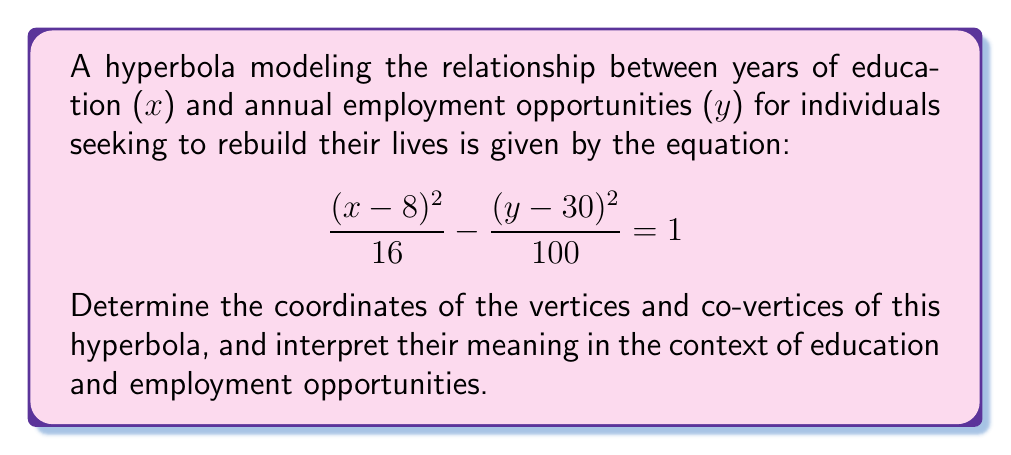Can you solve this math problem? Let's approach this step-by-step:

1) The standard form of a hyperbola with center (h,k) is:

   $$ \frac{(x-h)^2}{a^2} - \frac{(y-k)^2}{b^2} = 1 $$

   where the transverse axis is horizontal if $a^2 > b^2$, and vertical if $b^2 > a^2$.

2) Comparing our equation to the standard form:
   
   $h = 8$, $k = 30$, $a^2 = 16$, and $b^2 = 100$

3) Since $16 < 100$, the transverse axis is vertical.

4) The vertices are located $a$ units above and below the center:
   
   Vertices: $(8, 30 \pm 4)$ or $(8, 34)$ and $(8, 26)$

5) The co-vertices are located $b$ units left and right of the center:
   
   Co-vertices: $(8 \pm 10, 30)$ or $(18, 30)$ and $(-2, 30)$

6) Interpretation:
   - The center (8, 30) represents 8 years of education corresponding to 30 annual employment opportunities.
   - The vertices (8, 34) and (8, 26) show the maximum variation in employment opportunities at 8 years of education.
   - The co-vertices (18, 30) and (-2, 30) represent the minimum and maximum years of education that correspond to 30 annual employment opportunities.
Answer: Vertices: (8, 34) and (8, 26); Co-vertices: (18, 30) and (-2, 30) 